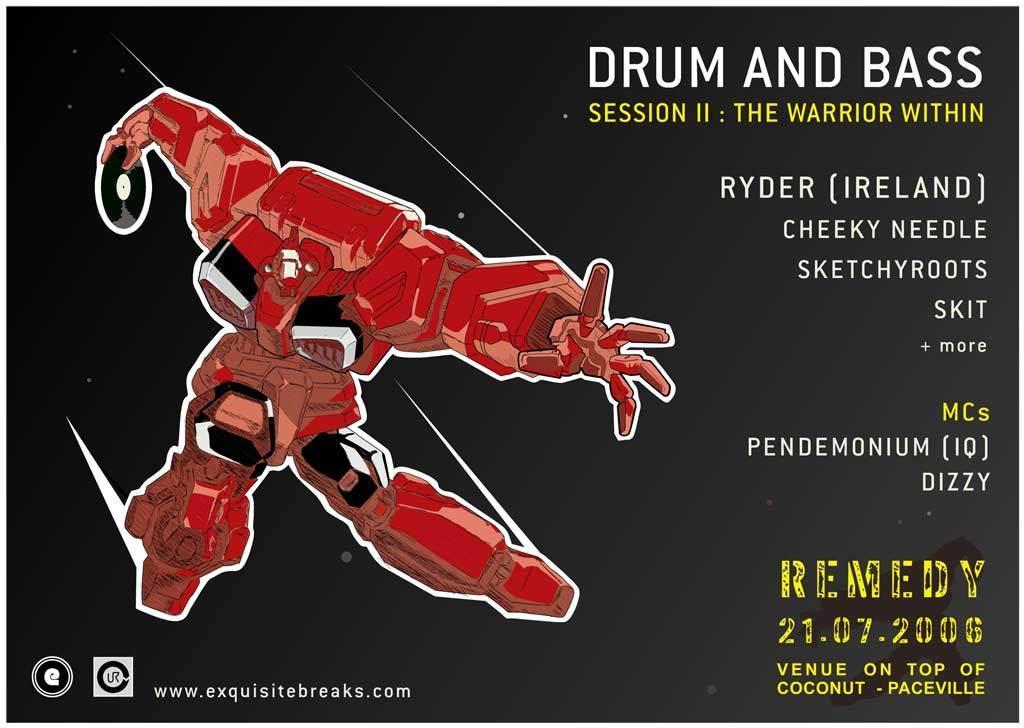Describe this image in one or two sentences. This is a image of a poster as we can see there is a picture of a robot on the left side of this image and there is a text on the right side of this image, and there is some text with logo at the bottom of this image. 